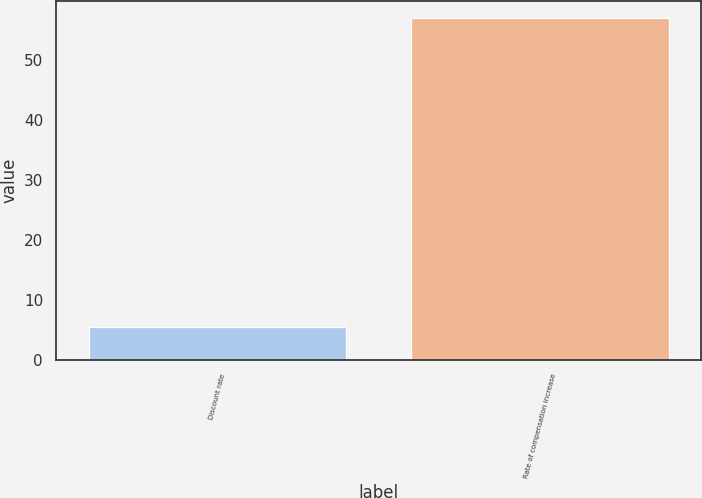Convert chart. <chart><loc_0><loc_0><loc_500><loc_500><bar_chart><fcel>Discount rate<fcel>Rate of compensation increase<nl><fcel>5.5<fcel>57<nl></chart> 